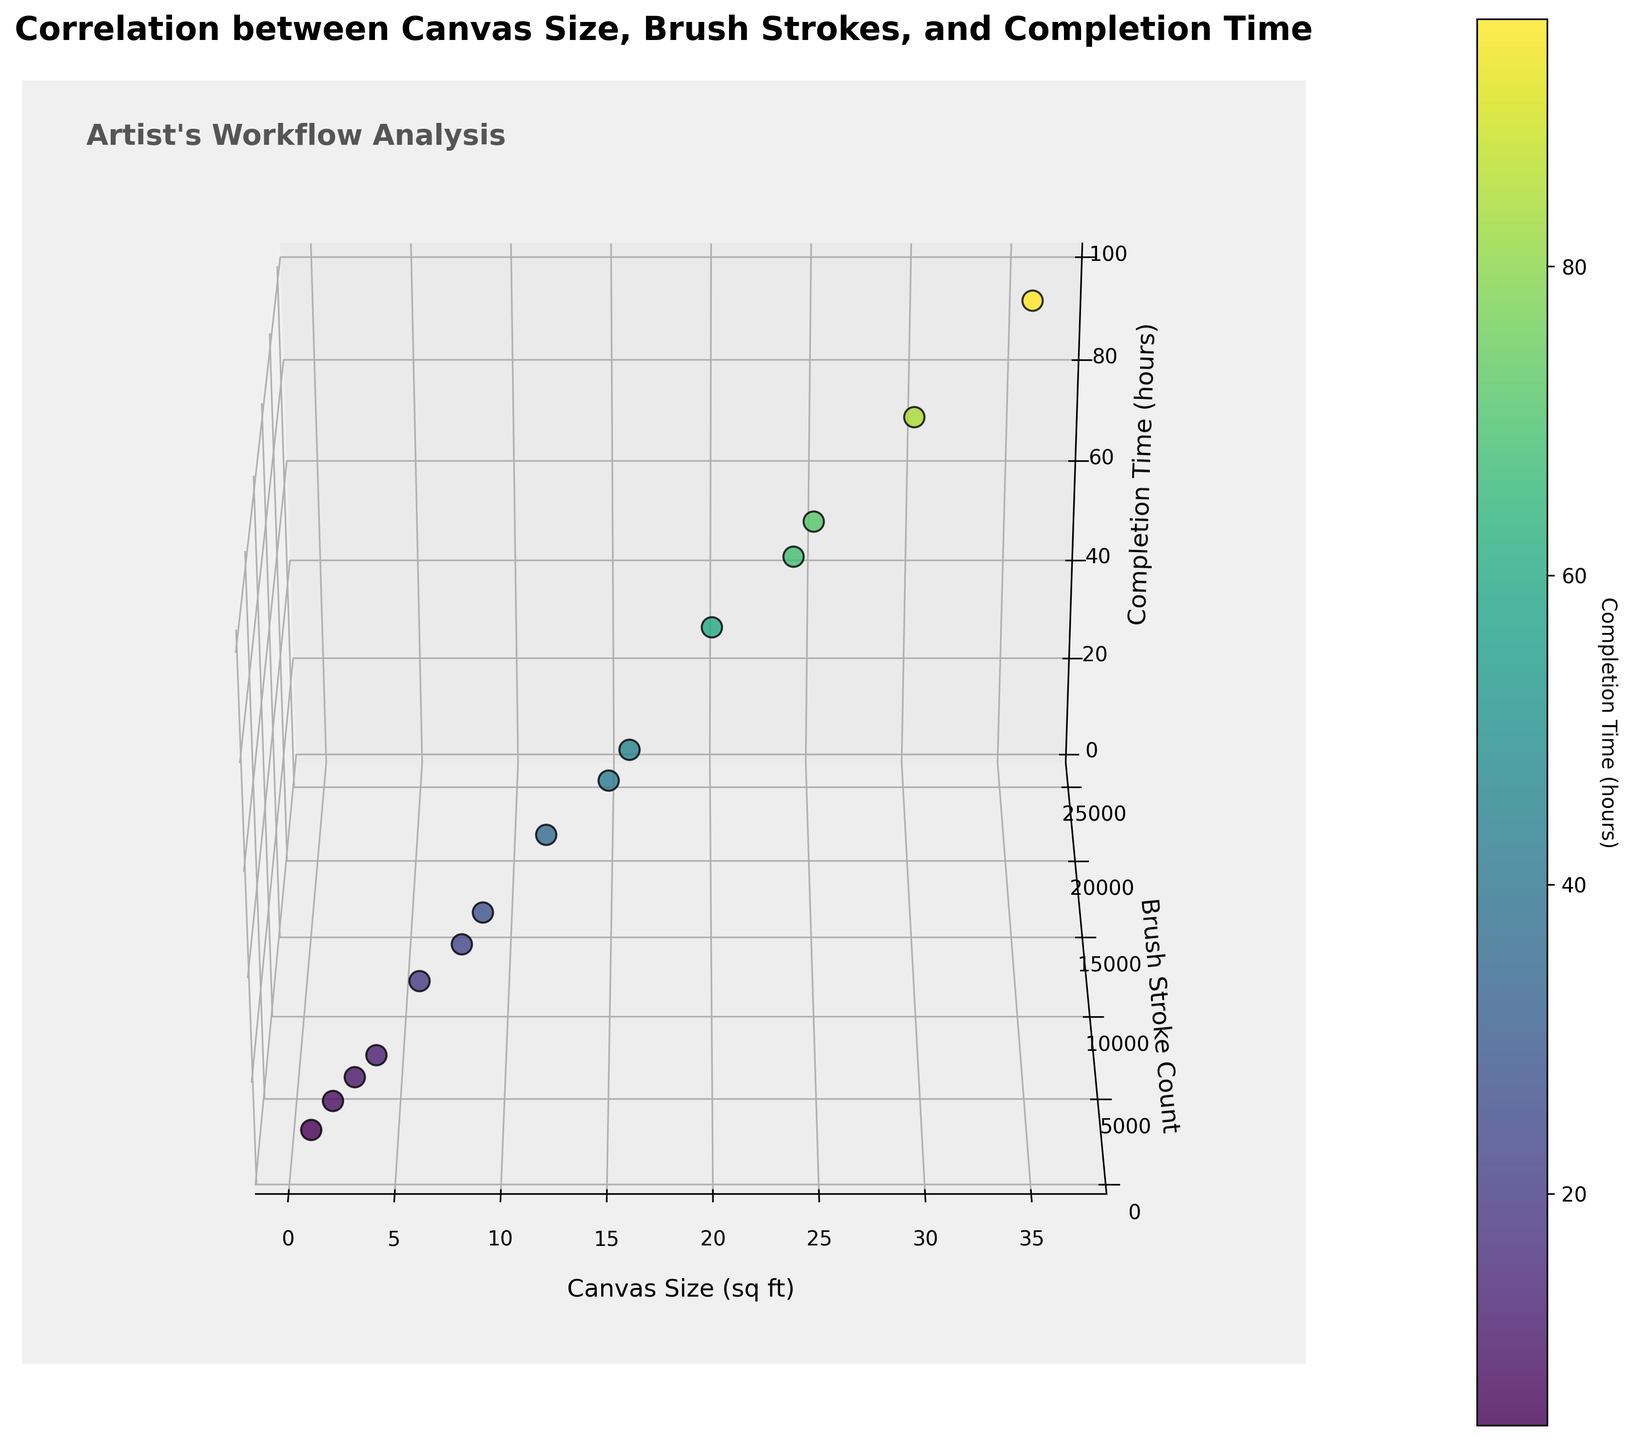How many data points are displayed in the 3D scatter plot? The plot shows 15 individual data points. You can count the number of unique points visualized in the graph.
Answer: 15 What color map is used to visualize the completion time? The color map utilized is 'viridis', which ranges from yellow to blue-green and purple, indicating different completion times.
Answer: viridis Which axis represents the brush stroke count? The brush stroke count is represented on the Y-axis, as indicated by the label on the corresponding axis in the 3D plot.
Answer: Y-axis How does the completion time trend with increasing canvas size? As the canvas size increases, the completion time generally increases too. This trend can be observed by looking at the data points, which show that higher canvas sizes correspond to higher completion times.
Answer: Increases Which axis shows the completion time? The Z-axis shows the completion time, clearly labeled on the vertical axis of the 3D scatter plot.
Answer: Z-axis What is the average brush stroke count for a canvas size greater than 20 sq ft? For canvas sizes greater than 20 sq ft, the brush stroke counts are 18000, 25000, and 21000. Adding these gives 18000 + 25000 + 21000 = 64000. Dividing by 3 (the number of points) gives an average of 64000 / 3 ≈ 21333.
Answer: 21333 Which data point has the highest completion time, and what is its canvas size? The highest completion time is 96 hours. Referring to the plot, this corresponds to a canvas size of 36 sq ft.
Answer: 36 sq ft Is there a noticeable correlation between brush stroke count and completion time? Yes, there is a noticeable positive correlation. As the brush stroke count increases, the completion time also tends to increase. This relationship is visually represented by the upward trend of data points along the brush stroke count and completion time axes.
Answer: Positive correlation What is the canvas size with the least brush strokes, and how long does it take to complete? The canvas size with the least brush strokes (1200 strokes) is 1 sq ft. It takes 5 hours to complete.
Answer: 5 hours Compare the completion times of canvas sizes 4 sq ft and 24 sq ft. The canvas size of 4 sq ft takes 12 hours to complete, while the canvas size of 24 sq ft takes 68 hours. The latter takes significantly longer.
Answer: 68 hours 